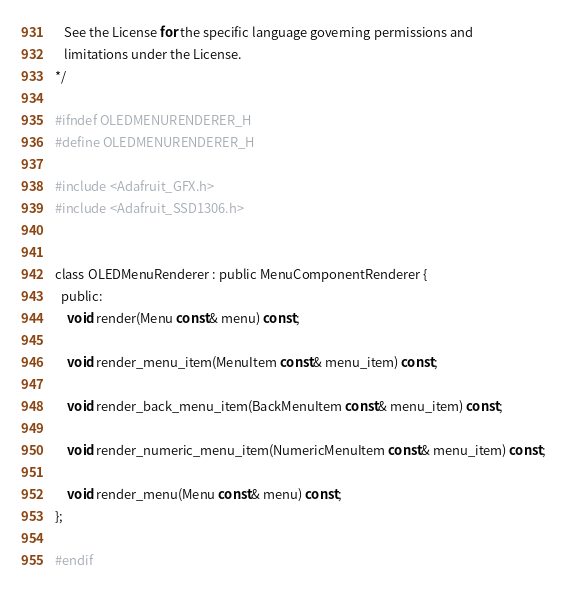<code> <loc_0><loc_0><loc_500><loc_500><_C_>   See the License for the specific language governing permissions and
   limitations under the License.
*/

#ifndef OLEDMENURENDERER_H
#define OLEDMENURENDERER_H

#include <Adafruit_GFX.h>
#include <Adafruit_SSD1306.h>


class OLEDMenuRenderer : public MenuComponentRenderer {
  public:
    void render(Menu const& menu) const;

    void render_menu_item(MenuItem const& menu_item) const;

    void render_back_menu_item(BackMenuItem const& menu_item) const;

    void render_numeric_menu_item(NumericMenuItem const& menu_item) const;

    void render_menu(Menu const& menu) const;
};

#endif
</code> 